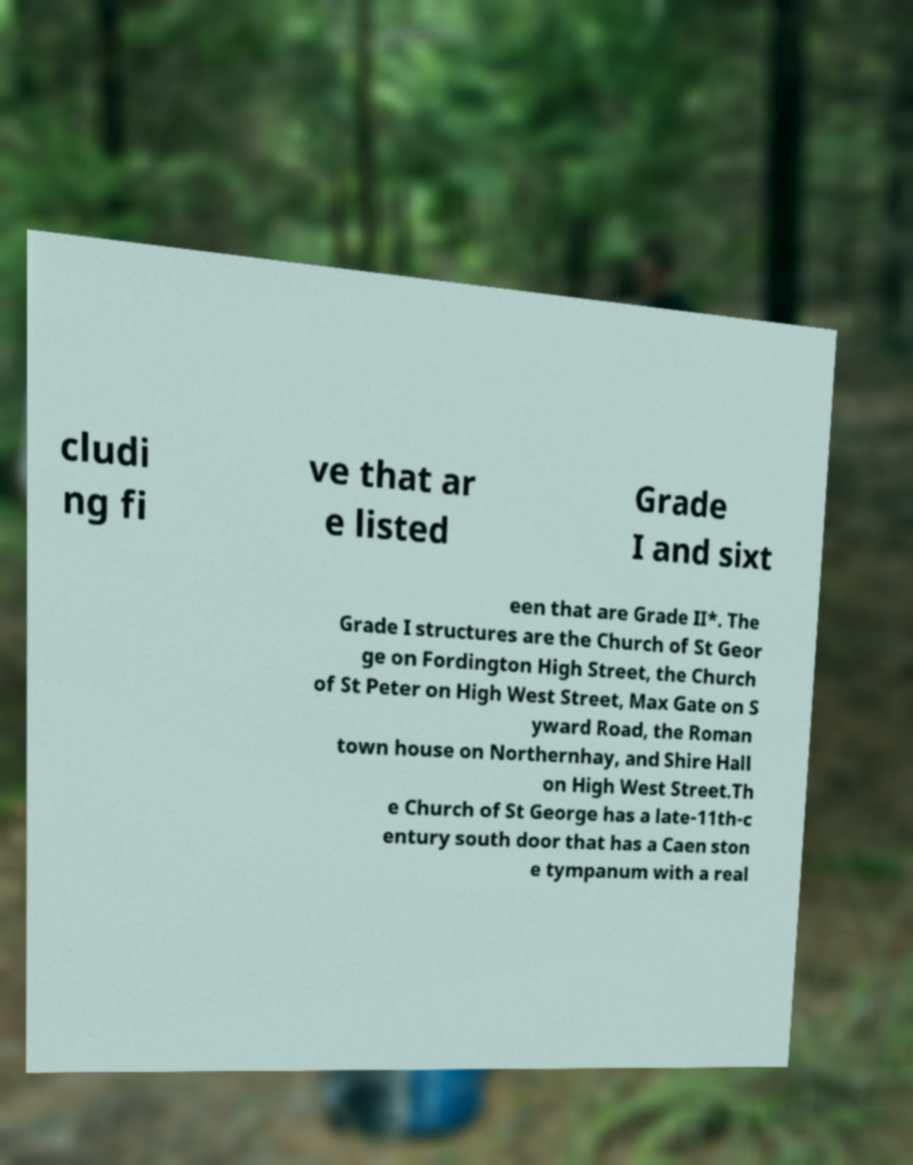Could you extract and type out the text from this image? cludi ng fi ve that ar e listed Grade I and sixt een that are Grade II*. The Grade I structures are the Church of St Geor ge on Fordington High Street, the Church of St Peter on High West Street, Max Gate on S yward Road, the Roman town house on Northernhay, and Shire Hall on High West Street.Th e Church of St George has a late-11th-c entury south door that has a Caen ston e tympanum with a real 